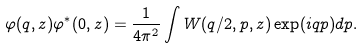Convert formula to latex. <formula><loc_0><loc_0><loc_500><loc_500>\varphi ( q , z ) \varphi ^ { * } ( 0 , z ) = \frac { 1 } { 4 \pi ^ { 2 } } \int W ( q / 2 , p , z ) \exp ( i q p ) d p .</formula> 